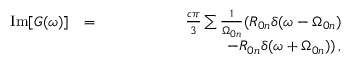Convert formula to latex. <formula><loc_0><loc_0><loc_500><loc_500>\begin{array} { r l r } { I m [ G ( \omega ) ] } & { = } & { \frac { c \pi } { 3 } \sum \frac { 1 } { \Omega _ { 0 n } } ( R _ { 0 n } \delta ( \omega - \Omega _ { 0 n } ) } \\ & { \, - R _ { 0 n } \delta ( \omega + \Omega _ { 0 n } ) ) \, , } \end{array}</formula> 